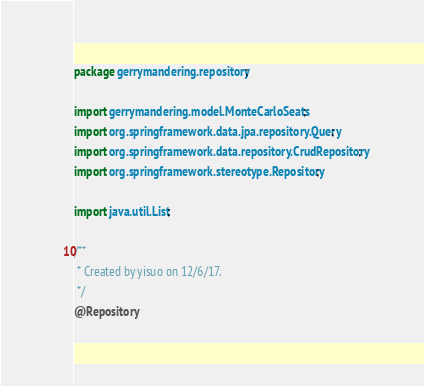<code> <loc_0><loc_0><loc_500><loc_500><_Java_>package gerrymandering.repository;

import gerrymandering.model.MonteCarloSeats;
import org.springframework.data.jpa.repository.Query;
import org.springframework.data.repository.CrudRepository;
import org.springframework.stereotype.Repository;

import java.util.List;

/**
 * Created by yisuo on 12/6/17.
 */
@Repository</code> 